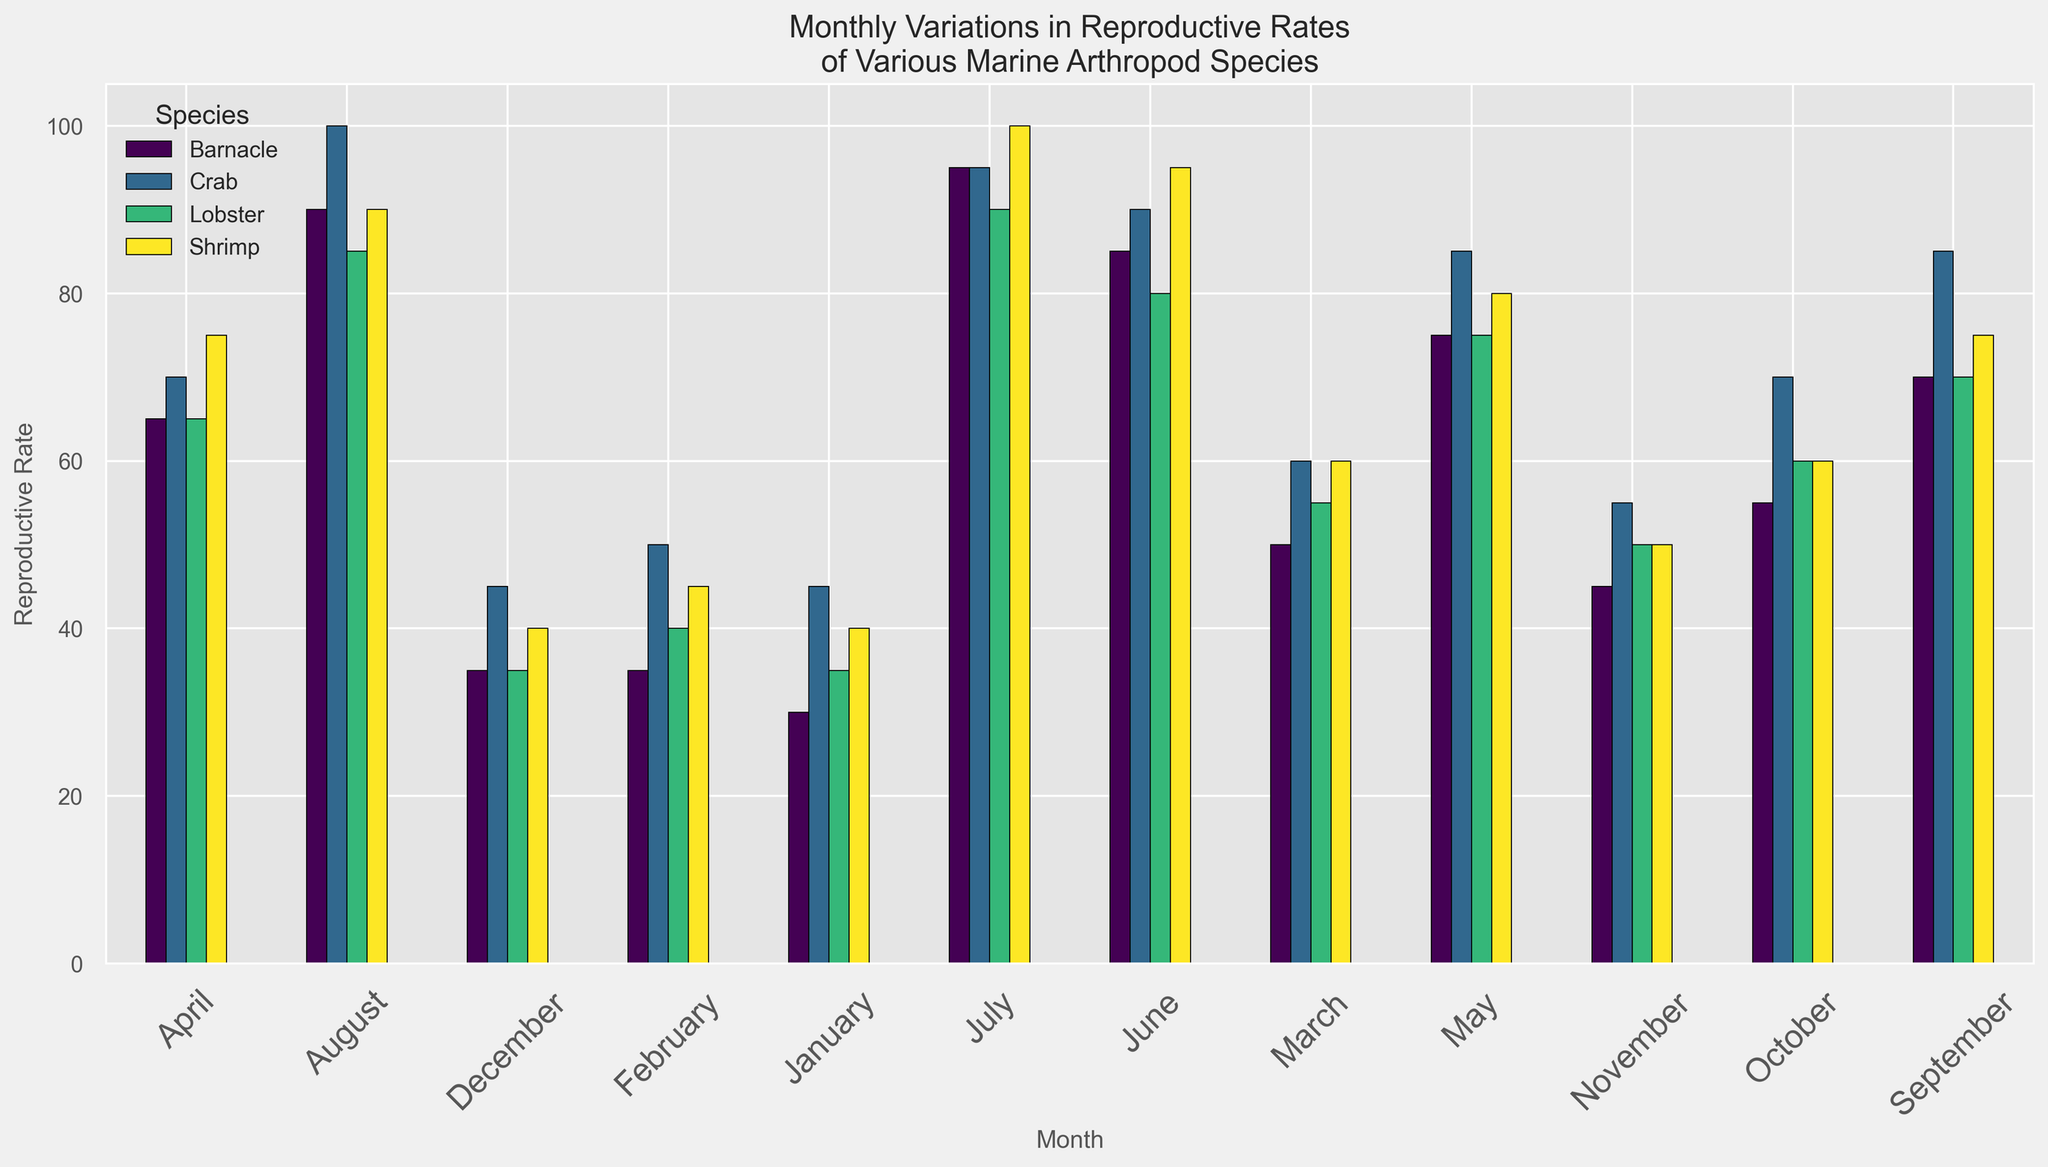What month has the highest reproductive rate for crabs? Look for the highest bar in the Crab category; it occurs in August, with a reproductive rate of 100.
Answer: August Which species shows the most significant increase in reproductive rate from January to July? Calculate the difference in reproductive rate between January and July for each species: 
Crab: 95 - 45 = 50
Shrimp: 100 - 40 = 60
Lobster: 90 - 35 = 55
Barnacle: 95 - 30 = 65 
Thus, Barnacle shows the most significant increase.
Answer: Barnacle In which month do lobster and shrimp have the same reproductive rate? Scan the bars graphically; in November, both Lobster and Shrimp have the same reproductive rate of 50.
Answer: November What is the average reproductive rate for barnacles in the first quarter (January, February, March)? Add the reproductive rates for Barnacle (January: 30, February: 35, March: 50), then divide by 3. (30+35+50) / 3 = 38.33
Answer: 38.33 Which species has the lowest reproductive rate in December, and what is it? Examine the bars for December visually; the shortest bar belongs to Lobster with a reproductive rate of 35.
Answer: Lobster, 35 Are there any months where all species show a reproductive rate above 50? Check each month visually; July is the only month where all bars (Crab: 95, Shrimp: 100, Lobster: 90, Barnacle: 95) are above 50.
Answer: July How does the reproductive rate of crabs in September compare to that in June? Compare the heights of the bars in September and June for Crabs; in September it's 85, and in June it's 90, so it decreased by 5.
Answer: Lower by 5 What's the difference in reproductive rate for shrimp between the peak and the trough month? Identify the highest (July: 100) and lowest (January: 40), then calculate the difference, 100 - 40 = 60.
Answer: 60 Which species has the most consistent reproductive rate throughout the year? Visually compare the variance in bar height across months for all species; Shrimp has relatively smooth changes throughout months.
Answer: Shrimp What is the cumulative reproductive rate of all species combined in May? Sum the reproductive rates of all species in May: 
Crab: 85, Shrimp: 80, Lobster: 75, Barnacle: 75; so, 85+80+75+75 = 315.
Answer: 315 